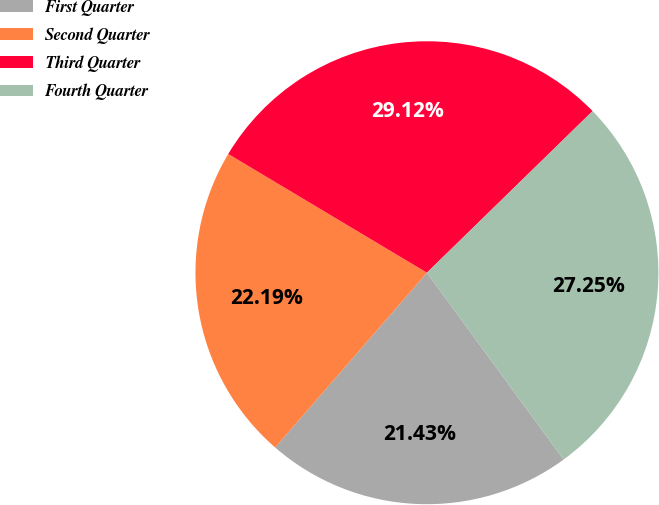<chart> <loc_0><loc_0><loc_500><loc_500><pie_chart><fcel>First Quarter<fcel>Second Quarter<fcel>Third Quarter<fcel>Fourth Quarter<nl><fcel>21.43%<fcel>22.19%<fcel>29.12%<fcel>27.25%<nl></chart> 